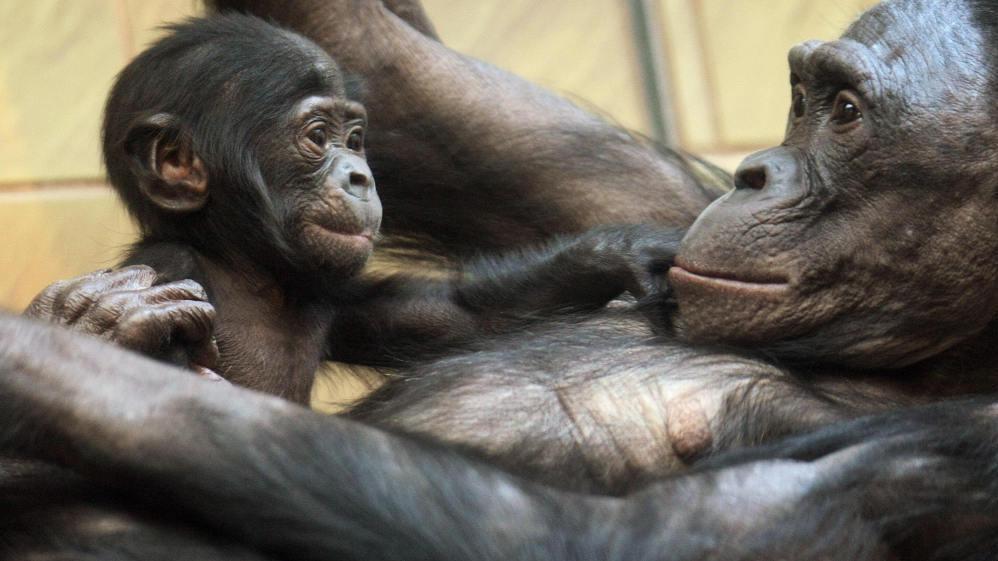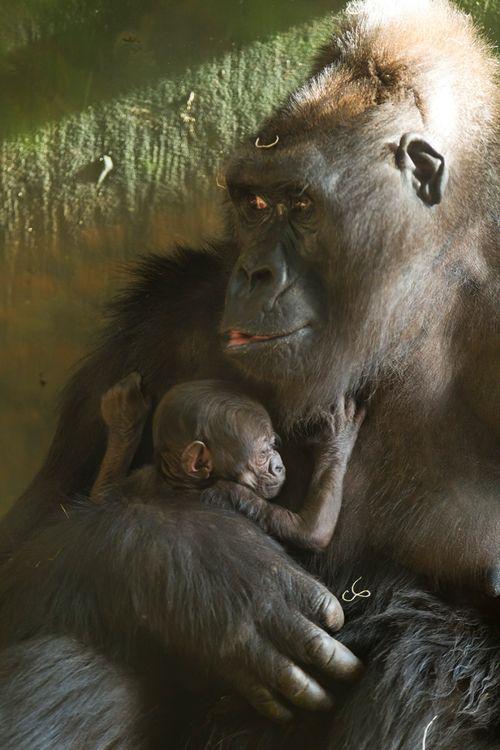The first image is the image on the left, the second image is the image on the right. Evaluate the accuracy of this statement regarding the images: "a gorilla is sitting in the grass holding her infant". Is it true? Answer yes or no. No. The first image is the image on the left, the second image is the image on the right. For the images displayed, is the sentence "Each image shows a baby ape nursing at its mother's breast." factually correct? Answer yes or no. No. 